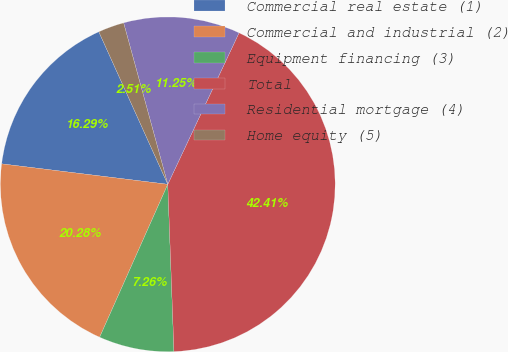Convert chart. <chart><loc_0><loc_0><loc_500><loc_500><pie_chart><fcel>Commercial real estate (1)<fcel>Commercial and industrial (2)<fcel>Equipment financing (3)<fcel>Total<fcel>Residential mortgage (4)<fcel>Home equity (5)<nl><fcel>16.29%<fcel>20.28%<fcel>7.26%<fcel>42.41%<fcel>11.25%<fcel>2.51%<nl></chart> 